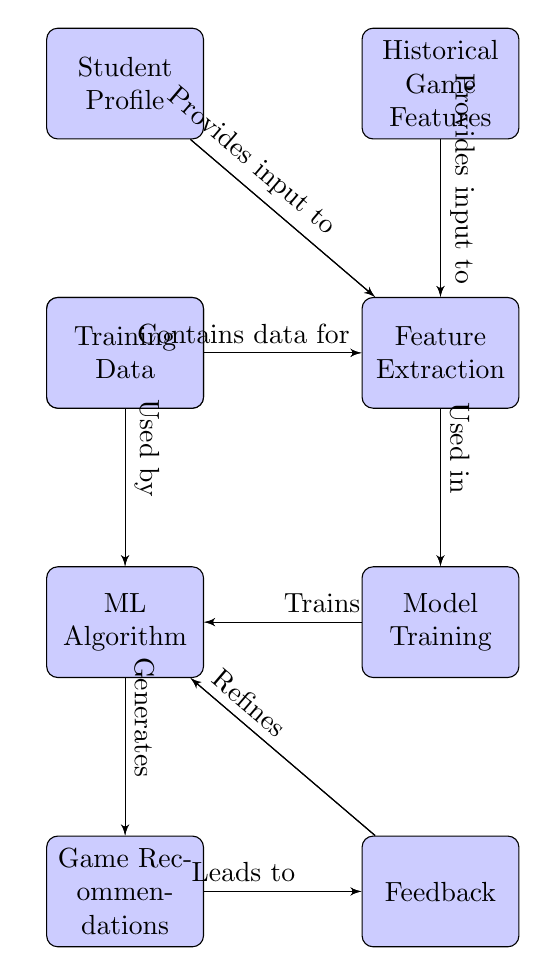What node provides input to feature extraction? The diagram shows that both the Student Profile and Historical Game Features nodes provide input to the Feature Extraction node, as indicated by the arrows leading to it.
Answer: Student Profile, Historical Game Features How many blocks are in the diagram? By counting all the distinct blocks, we find there are eight blocks: Student Profile, Historical Game Features, Game Database, Feature Extraction, Model Training, ML Algorithm, Game Recommendations, and Feedback.
Answer: 8 What does the ML Algorithm generate? According to the diagram, the arrow coming out of the ML Algorithm points to the Game Recommendations block, indicating that this is the output generated by the algorithm.
Answer: Game Recommendations Which block leads to feedback? The diagram clearly indicates that the Game Recommendations block directly leads to the Feedback block, as shown by the arrow connecting them.
Answer: Game Recommendations What is used to train the ML Algorithm? The training process for the ML Algorithm relies on the output from the Model Training block, which is connected through an arrow pointing towards it, as indicated in the diagram.
Answer: Model Training What flow leads back to the ML Algorithm? The diagram shows that the Feedback block leads back to the ML Algorithm, suggesting that input from feedback processes is used to refine the ML Algorithm itself.
Answer: Feedback What kind of data is used by the ML Algorithm? The diagram specifies that the Training Data node feeds into the ML Algorithm, indicating that this data is crucial for its operation.
Answer: Training Data Which block contains data for feature extraction? The Game Database block contains data necessary for feature extraction, as indicated by the line pointing from Game Database to Feature Extraction.
Answer: Game Database 